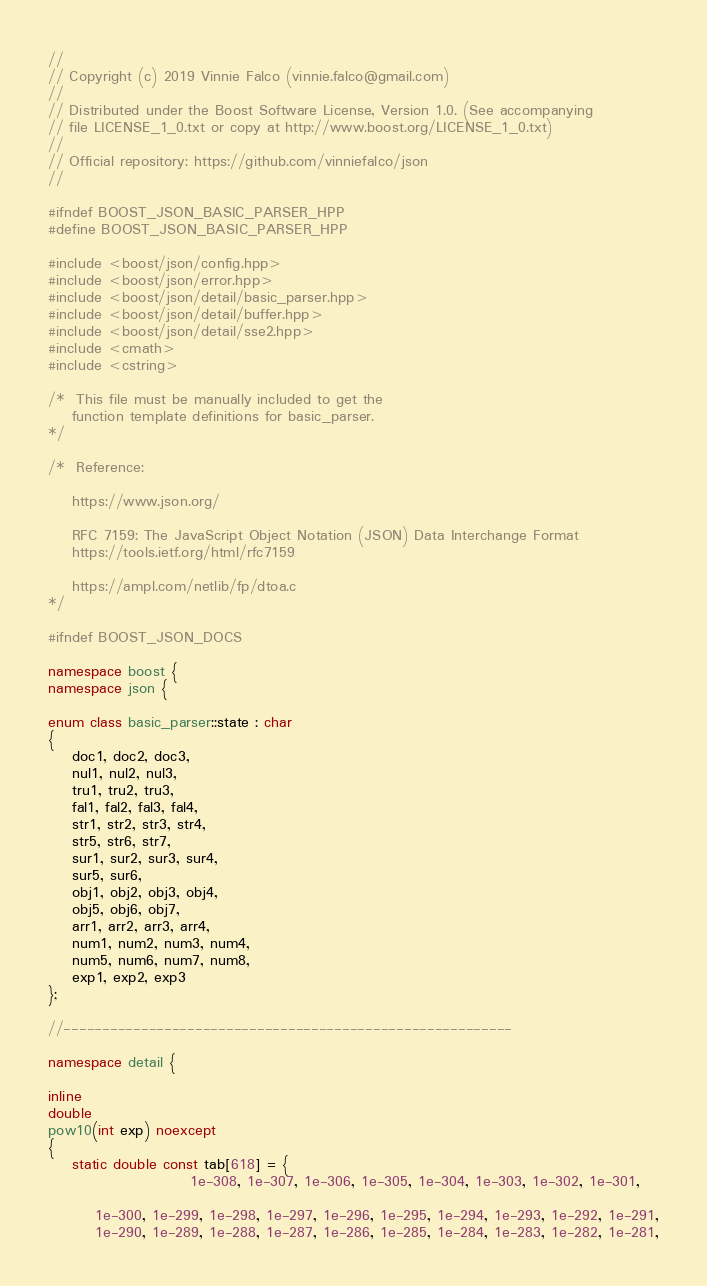Convert code to text. <code><loc_0><loc_0><loc_500><loc_500><_C++_>//
// Copyright (c) 2019 Vinnie Falco (vinnie.falco@gmail.com)
//
// Distributed under the Boost Software License, Version 1.0. (See accompanying
// file LICENSE_1_0.txt or copy at http://www.boost.org/LICENSE_1_0.txt)
//
// Official repository: https://github.com/vinniefalco/json
//

#ifndef BOOST_JSON_BASIC_PARSER_HPP
#define BOOST_JSON_BASIC_PARSER_HPP

#include <boost/json/config.hpp>
#include <boost/json/error.hpp>
#include <boost/json/detail/basic_parser.hpp>
#include <boost/json/detail/buffer.hpp>
#include <boost/json/detail/sse2.hpp>
#include <cmath>
#include <cstring>

/*  This file must be manually included to get the
    function template definitions for basic_parser.
*/

/*  Reference:

    https://www.json.org/

    RFC 7159: The JavaScript Object Notation (JSON) Data Interchange Format
    https://tools.ietf.org/html/rfc7159

    https://ampl.com/netlib/fp/dtoa.c
*/

#ifndef BOOST_JSON_DOCS

namespace boost {
namespace json {

enum class basic_parser::state : char
{
    doc1, doc2, doc3,
    nul1, nul2, nul3,
    tru1, tru2, tru3,
    fal1, fal2, fal3, fal4,
    str1, str2, str3, str4,
    str5, str6, str7,
    sur1, sur2, sur3, sur4,
    sur5, sur6,
    obj1, obj2, obj3, obj4,
    obj5, obj6, obj7,
    arr1, arr2, arr3, arr4,
    num1, num2, num3, num4,
    num5, num6, num7, num8,
    exp1, exp2, exp3
};

//----------------------------------------------------------

namespace detail {

inline
double
pow10(int exp) noexcept
{
    static double const tab[618] = {
                        1e-308, 1e-307, 1e-306, 1e-305, 1e-304, 1e-303, 1e-302, 1e-301,

        1e-300, 1e-299, 1e-298, 1e-297, 1e-296, 1e-295, 1e-294, 1e-293, 1e-292, 1e-291,
        1e-290, 1e-289, 1e-288, 1e-287, 1e-286, 1e-285, 1e-284, 1e-283, 1e-282, 1e-281,</code> 